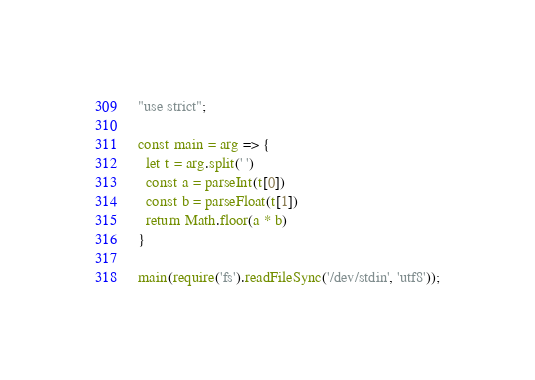Convert code to text. <code><loc_0><loc_0><loc_500><loc_500><_JavaScript_>"use strict";

const main = arg => {
  let t = arg.split(' ')
  const a = parseInt(t[0])
  const b = parseFloat(t[1])
  return Math.floor(a * b)
}

main(require('fs').readFileSync('/dev/stdin', 'utf8'));
</code> 